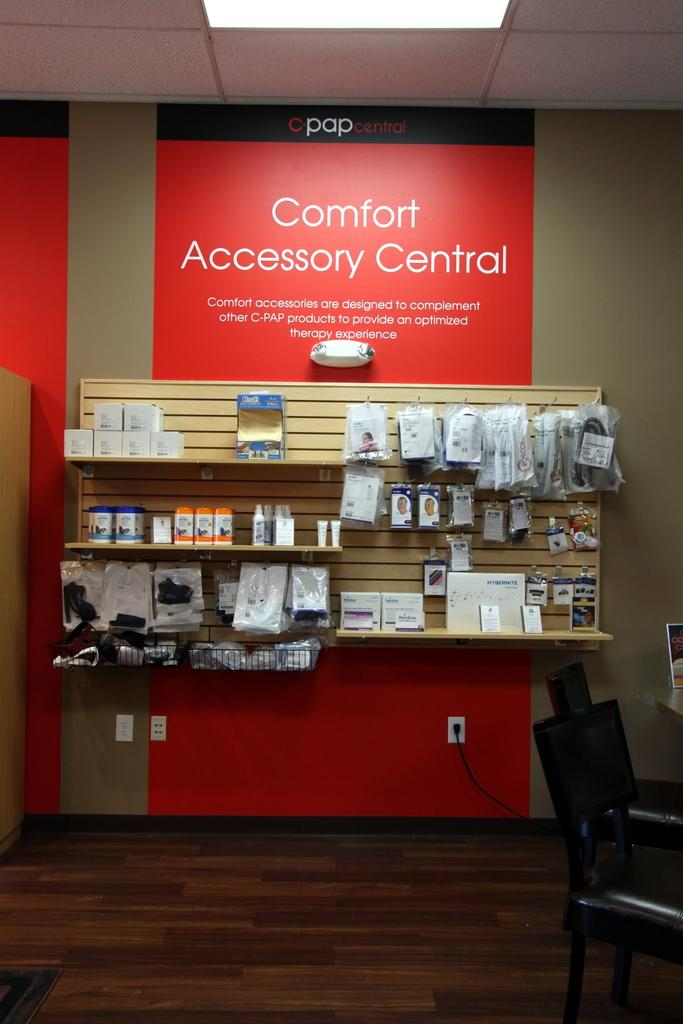<image>
Share a concise interpretation of the image provided. A display offers a variety of comfort accessories presented on shelves. 